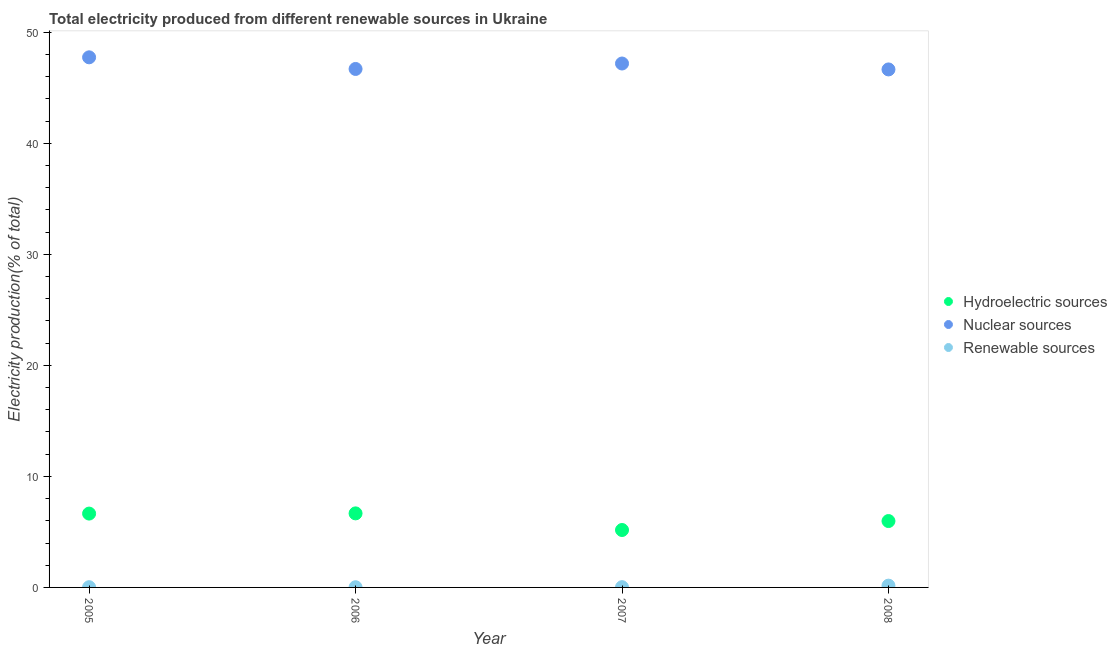What is the percentage of electricity produced by renewable sources in 2007?
Ensure brevity in your answer.  0.02. Across all years, what is the maximum percentage of electricity produced by nuclear sources?
Your answer should be compact. 47.74. Across all years, what is the minimum percentage of electricity produced by nuclear sources?
Provide a succinct answer. 46.65. In which year was the percentage of electricity produced by hydroelectric sources minimum?
Your response must be concise. 2007. What is the total percentage of electricity produced by nuclear sources in the graph?
Give a very brief answer. 188.27. What is the difference between the percentage of electricity produced by renewable sources in 2005 and that in 2006?
Your answer should be compact. 0. What is the difference between the percentage of electricity produced by renewable sources in 2007 and the percentage of electricity produced by nuclear sources in 2005?
Offer a terse response. -47.72. What is the average percentage of electricity produced by nuclear sources per year?
Offer a very short reply. 47.07. In the year 2007, what is the difference between the percentage of electricity produced by hydroelectric sources and percentage of electricity produced by renewable sources?
Make the answer very short. 5.15. What is the ratio of the percentage of electricity produced by nuclear sources in 2006 to that in 2008?
Offer a terse response. 1. Is the percentage of electricity produced by hydroelectric sources in 2005 less than that in 2007?
Your answer should be compact. No. Is the difference between the percentage of electricity produced by nuclear sources in 2005 and 2006 greater than the difference between the percentage of electricity produced by hydroelectric sources in 2005 and 2006?
Your answer should be compact. Yes. What is the difference between the highest and the second highest percentage of electricity produced by renewable sources?
Offer a terse response. 0.14. What is the difference between the highest and the lowest percentage of electricity produced by nuclear sources?
Make the answer very short. 1.09. Is it the case that in every year, the sum of the percentage of electricity produced by hydroelectric sources and percentage of electricity produced by nuclear sources is greater than the percentage of electricity produced by renewable sources?
Your response must be concise. Yes. Does the percentage of electricity produced by renewable sources monotonically increase over the years?
Offer a terse response. No. Is the percentage of electricity produced by hydroelectric sources strictly greater than the percentage of electricity produced by nuclear sources over the years?
Ensure brevity in your answer.  No. Is the percentage of electricity produced by renewable sources strictly less than the percentage of electricity produced by nuclear sources over the years?
Your response must be concise. Yes. How many dotlines are there?
Make the answer very short. 3. How many years are there in the graph?
Ensure brevity in your answer.  4. Are the values on the major ticks of Y-axis written in scientific E-notation?
Your answer should be compact. No. Does the graph contain any zero values?
Your answer should be very brief. No. Where does the legend appear in the graph?
Offer a very short reply. Center right. What is the title of the graph?
Your answer should be compact. Total electricity produced from different renewable sources in Ukraine. Does "Industrial Nitrous Oxide" appear as one of the legend labels in the graph?
Offer a very short reply. No. What is the label or title of the X-axis?
Provide a succinct answer. Year. What is the Electricity production(% of total) in Hydroelectric sources in 2005?
Your answer should be very brief. 6.65. What is the Electricity production(% of total) in Nuclear sources in 2005?
Offer a very short reply. 47.74. What is the Electricity production(% of total) in Renewable sources in 2005?
Offer a very short reply. 0.02. What is the Electricity production(% of total) of Hydroelectric sources in 2006?
Your answer should be very brief. 6.67. What is the Electricity production(% of total) of Nuclear sources in 2006?
Keep it short and to the point. 46.69. What is the Electricity production(% of total) of Renewable sources in 2006?
Offer a very short reply. 0.02. What is the Electricity production(% of total) in Hydroelectric sources in 2007?
Offer a terse response. 5.17. What is the Electricity production(% of total) of Nuclear sources in 2007?
Offer a very short reply. 47.18. What is the Electricity production(% of total) in Renewable sources in 2007?
Make the answer very short. 0.02. What is the Electricity production(% of total) of Hydroelectric sources in 2008?
Offer a terse response. 5.98. What is the Electricity production(% of total) in Nuclear sources in 2008?
Your answer should be very brief. 46.65. What is the Electricity production(% of total) of Renewable sources in 2008?
Give a very brief answer. 0.16. Across all years, what is the maximum Electricity production(% of total) in Hydroelectric sources?
Offer a terse response. 6.67. Across all years, what is the maximum Electricity production(% of total) in Nuclear sources?
Provide a succinct answer. 47.74. Across all years, what is the maximum Electricity production(% of total) of Renewable sources?
Ensure brevity in your answer.  0.16. Across all years, what is the minimum Electricity production(% of total) in Hydroelectric sources?
Give a very brief answer. 5.17. Across all years, what is the minimum Electricity production(% of total) in Nuclear sources?
Your response must be concise. 46.65. Across all years, what is the minimum Electricity production(% of total) in Renewable sources?
Make the answer very short. 0.02. What is the total Electricity production(% of total) in Hydroelectric sources in the graph?
Your answer should be very brief. 24.47. What is the total Electricity production(% of total) of Nuclear sources in the graph?
Your answer should be very brief. 188.27. What is the total Electricity production(% of total) in Renewable sources in the graph?
Make the answer very short. 0.22. What is the difference between the Electricity production(% of total) in Hydroelectric sources in 2005 and that in 2006?
Ensure brevity in your answer.  -0.02. What is the difference between the Electricity production(% of total) in Nuclear sources in 2005 and that in 2006?
Your answer should be very brief. 1.05. What is the difference between the Electricity production(% of total) in Renewable sources in 2005 and that in 2006?
Provide a short and direct response. 0. What is the difference between the Electricity production(% of total) in Hydroelectric sources in 2005 and that in 2007?
Offer a terse response. 1.48. What is the difference between the Electricity production(% of total) of Nuclear sources in 2005 and that in 2007?
Make the answer very short. 0.56. What is the difference between the Electricity production(% of total) of Renewable sources in 2005 and that in 2007?
Provide a short and direct response. -0. What is the difference between the Electricity production(% of total) in Hydroelectric sources in 2005 and that in 2008?
Offer a terse response. 0.67. What is the difference between the Electricity production(% of total) in Nuclear sources in 2005 and that in 2008?
Offer a terse response. 1.09. What is the difference between the Electricity production(% of total) of Renewable sources in 2005 and that in 2008?
Provide a short and direct response. -0.14. What is the difference between the Electricity production(% of total) of Hydroelectric sources in 2006 and that in 2007?
Provide a succinct answer. 1.5. What is the difference between the Electricity production(% of total) in Nuclear sources in 2006 and that in 2007?
Provide a short and direct response. -0.49. What is the difference between the Electricity production(% of total) of Renewable sources in 2006 and that in 2007?
Your answer should be very brief. -0. What is the difference between the Electricity production(% of total) of Hydroelectric sources in 2006 and that in 2008?
Offer a terse response. 0.69. What is the difference between the Electricity production(% of total) in Nuclear sources in 2006 and that in 2008?
Make the answer very short. 0.04. What is the difference between the Electricity production(% of total) of Renewable sources in 2006 and that in 2008?
Make the answer very short. -0.14. What is the difference between the Electricity production(% of total) of Hydroelectric sources in 2007 and that in 2008?
Offer a terse response. -0.81. What is the difference between the Electricity production(% of total) of Nuclear sources in 2007 and that in 2008?
Provide a short and direct response. 0.53. What is the difference between the Electricity production(% of total) in Renewable sources in 2007 and that in 2008?
Keep it short and to the point. -0.14. What is the difference between the Electricity production(% of total) of Hydroelectric sources in 2005 and the Electricity production(% of total) of Nuclear sources in 2006?
Your answer should be compact. -40.04. What is the difference between the Electricity production(% of total) in Hydroelectric sources in 2005 and the Electricity production(% of total) in Renewable sources in 2006?
Your answer should be compact. 6.63. What is the difference between the Electricity production(% of total) of Nuclear sources in 2005 and the Electricity production(% of total) of Renewable sources in 2006?
Provide a short and direct response. 47.72. What is the difference between the Electricity production(% of total) in Hydroelectric sources in 2005 and the Electricity production(% of total) in Nuclear sources in 2007?
Make the answer very short. -40.53. What is the difference between the Electricity production(% of total) of Hydroelectric sources in 2005 and the Electricity production(% of total) of Renewable sources in 2007?
Provide a short and direct response. 6.63. What is the difference between the Electricity production(% of total) in Nuclear sources in 2005 and the Electricity production(% of total) in Renewable sources in 2007?
Give a very brief answer. 47.72. What is the difference between the Electricity production(% of total) in Hydroelectric sources in 2005 and the Electricity production(% of total) in Nuclear sources in 2008?
Make the answer very short. -40. What is the difference between the Electricity production(% of total) of Hydroelectric sources in 2005 and the Electricity production(% of total) of Renewable sources in 2008?
Offer a terse response. 6.49. What is the difference between the Electricity production(% of total) of Nuclear sources in 2005 and the Electricity production(% of total) of Renewable sources in 2008?
Make the answer very short. 47.58. What is the difference between the Electricity production(% of total) in Hydroelectric sources in 2006 and the Electricity production(% of total) in Nuclear sources in 2007?
Your answer should be very brief. -40.51. What is the difference between the Electricity production(% of total) of Hydroelectric sources in 2006 and the Electricity production(% of total) of Renewable sources in 2007?
Keep it short and to the point. 6.65. What is the difference between the Electricity production(% of total) in Nuclear sources in 2006 and the Electricity production(% of total) in Renewable sources in 2007?
Keep it short and to the point. 46.67. What is the difference between the Electricity production(% of total) in Hydroelectric sources in 2006 and the Electricity production(% of total) in Nuclear sources in 2008?
Keep it short and to the point. -39.98. What is the difference between the Electricity production(% of total) of Hydroelectric sources in 2006 and the Electricity production(% of total) of Renewable sources in 2008?
Provide a short and direct response. 6.51. What is the difference between the Electricity production(% of total) in Nuclear sources in 2006 and the Electricity production(% of total) in Renewable sources in 2008?
Offer a terse response. 46.53. What is the difference between the Electricity production(% of total) of Hydroelectric sources in 2007 and the Electricity production(% of total) of Nuclear sources in 2008?
Your answer should be compact. -41.48. What is the difference between the Electricity production(% of total) in Hydroelectric sources in 2007 and the Electricity production(% of total) in Renewable sources in 2008?
Your response must be concise. 5.01. What is the difference between the Electricity production(% of total) in Nuclear sources in 2007 and the Electricity production(% of total) in Renewable sources in 2008?
Give a very brief answer. 47.02. What is the average Electricity production(% of total) in Hydroelectric sources per year?
Keep it short and to the point. 6.12. What is the average Electricity production(% of total) in Nuclear sources per year?
Ensure brevity in your answer.  47.07. What is the average Electricity production(% of total) of Renewable sources per year?
Keep it short and to the point. 0.06. In the year 2005, what is the difference between the Electricity production(% of total) of Hydroelectric sources and Electricity production(% of total) of Nuclear sources?
Offer a terse response. -41.09. In the year 2005, what is the difference between the Electricity production(% of total) in Hydroelectric sources and Electricity production(% of total) in Renewable sources?
Give a very brief answer. 6.63. In the year 2005, what is the difference between the Electricity production(% of total) of Nuclear sources and Electricity production(% of total) of Renewable sources?
Ensure brevity in your answer.  47.72. In the year 2006, what is the difference between the Electricity production(% of total) of Hydroelectric sources and Electricity production(% of total) of Nuclear sources?
Offer a terse response. -40.02. In the year 2006, what is the difference between the Electricity production(% of total) of Hydroelectric sources and Electricity production(% of total) of Renewable sources?
Your answer should be very brief. 6.65. In the year 2006, what is the difference between the Electricity production(% of total) of Nuclear sources and Electricity production(% of total) of Renewable sources?
Provide a short and direct response. 46.67. In the year 2007, what is the difference between the Electricity production(% of total) in Hydroelectric sources and Electricity production(% of total) in Nuclear sources?
Ensure brevity in your answer.  -42.01. In the year 2007, what is the difference between the Electricity production(% of total) in Hydroelectric sources and Electricity production(% of total) in Renewable sources?
Provide a succinct answer. 5.15. In the year 2007, what is the difference between the Electricity production(% of total) in Nuclear sources and Electricity production(% of total) in Renewable sources?
Provide a succinct answer. 47.16. In the year 2008, what is the difference between the Electricity production(% of total) in Hydroelectric sources and Electricity production(% of total) in Nuclear sources?
Your answer should be very brief. -40.67. In the year 2008, what is the difference between the Electricity production(% of total) in Hydroelectric sources and Electricity production(% of total) in Renewable sources?
Ensure brevity in your answer.  5.82. In the year 2008, what is the difference between the Electricity production(% of total) of Nuclear sources and Electricity production(% of total) of Renewable sources?
Offer a very short reply. 46.49. What is the ratio of the Electricity production(% of total) in Nuclear sources in 2005 to that in 2006?
Your answer should be compact. 1.02. What is the ratio of the Electricity production(% of total) of Renewable sources in 2005 to that in 2006?
Offer a terse response. 1.13. What is the ratio of the Electricity production(% of total) in Hydroelectric sources in 2005 to that in 2007?
Your response must be concise. 1.29. What is the ratio of the Electricity production(% of total) of Nuclear sources in 2005 to that in 2007?
Ensure brevity in your answer.  1.01. What is the ratio of the Electricity production(% of total) of Renewable sources in 2005 to that in 2007?
Make the answer very short. 0.89. What is the ratio of the Electricity production(% of total) in Hydroelectric sources in 2005 to that in 2008?
Give a very brief answer. 1.11. What is the ratio of the Electricity production(% of total) of Nuclear sources in 2005 to that in 2008?
Your answer should be very brief. 1.02. What is the ratio of the Electricity production(% of total) in Renewable sources in 2005 to that in 2008?
Provide a short and direct response. 0.13. What is the ratio of the Electricity production(% of total) in Hydroelectric sources in 2006 to that in 2007?
Offer a terse response. 1.29. What is the ratio of the Electricity production(% of total) in Renewable sources in 2006 to that in 2007?
Provide a short and direct response. 0.79. What is the ratio of the Electricity production(% of total) in Hydroelectric sources in 2006 to that in 2008?
Provide a short and direct response. 1.12. What is the ratio of the Electricity production(% of total) of Nuclear sources in 2006 to that in 2008?
Make the answer very short. 1. What is the ratio of the Electricity production(% of total) of Renewable sources in 2006 to that in 2008?
Make the answer very short. 0.11. What is the ratio of the Electricity production(% of total) of Hydroelectric sources in 2007 to that in 2008?
Make the answer very short. 0.87. What is the ratio of the Electricity production(% of total) in Nuclear sources in 2007 to that in 2008?
Offer a terse response. 1.01. What is the ratio of the Electricity production(% of total) of Renewable sources in 2007 to that in 2008?
Your answer should be very brief. 0.14. What is the difference between the highest and the second highest Electricity production(% of total) in Hydroelectric sources?
Keep it short and to the point. 0.02. What is the difference between the highest and the second highest Electricity production(% of total) in Nuclear sources?
Keep it short and to the point. 0.56. What is the difference between the highest and the second highest Electricity production(% of total) of Renewable sources?
Make the answer very short. 0.14. What is the difference between the highest and the lowest Electricity production(% of total) in Hydroelectric sources?
Ensure brevity in your answer.  1.5. What is the difference between the highest and the lowest Electricity production(% of total) in Nuclear sources?
Offer a very short reply. 1.09. What is the difference between the highest and the lowest Electricity production(% of total) of Renewable sources?
Make the answer very short. 0.14. 